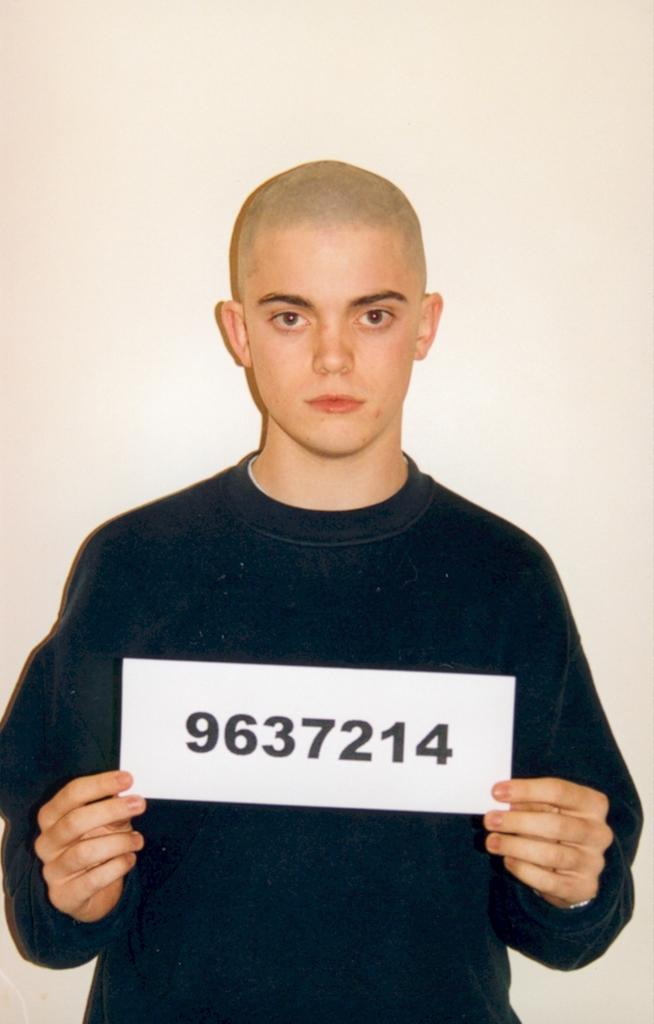Who is the main subject in the image? There is a boy in the image. What is the boy wearing? The boy is wearing a black t-shirt. What is the boy holding in his hand? The boy is holding a paper in his hand. What can be seen written on the paper? There are numbers written on the paper. What is the background of the image? There is a white wall behind the boy. Can you tell me how many trains are visible in the image? There are no trains present in the image. Is the boy swimming in the image? The boy is not swimming in the image; he is standing in front of a white wall. 